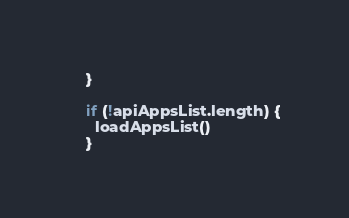Convert code to text. <code><loc_0><loc_0><loc_500><loc_500><_TypeScript_>    }

    if (!apiAppsList.length) {
      loadAppsList()
    }</code> 